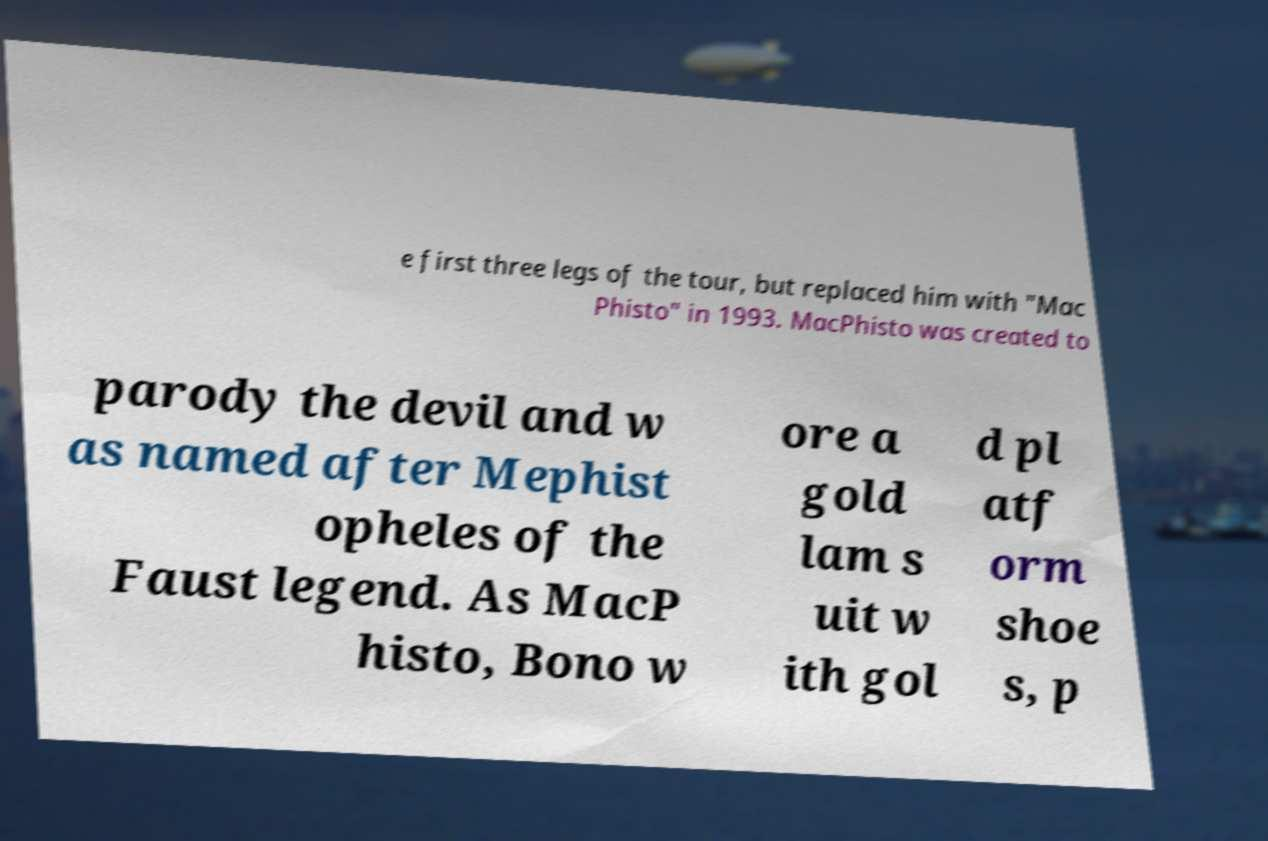There's text embedded in this image that I need extracted. Can you transcribe it verbatim? e first three legs of the tour, but replaced him with "Mac Phisto" in 1993. MacPhisto was created to parody the devil and w as named after Mephist opheles of the Faust legend. As MacP histo, Bono w ore a gold lam s uit w ith gol d pl atf orm shoe s, p 